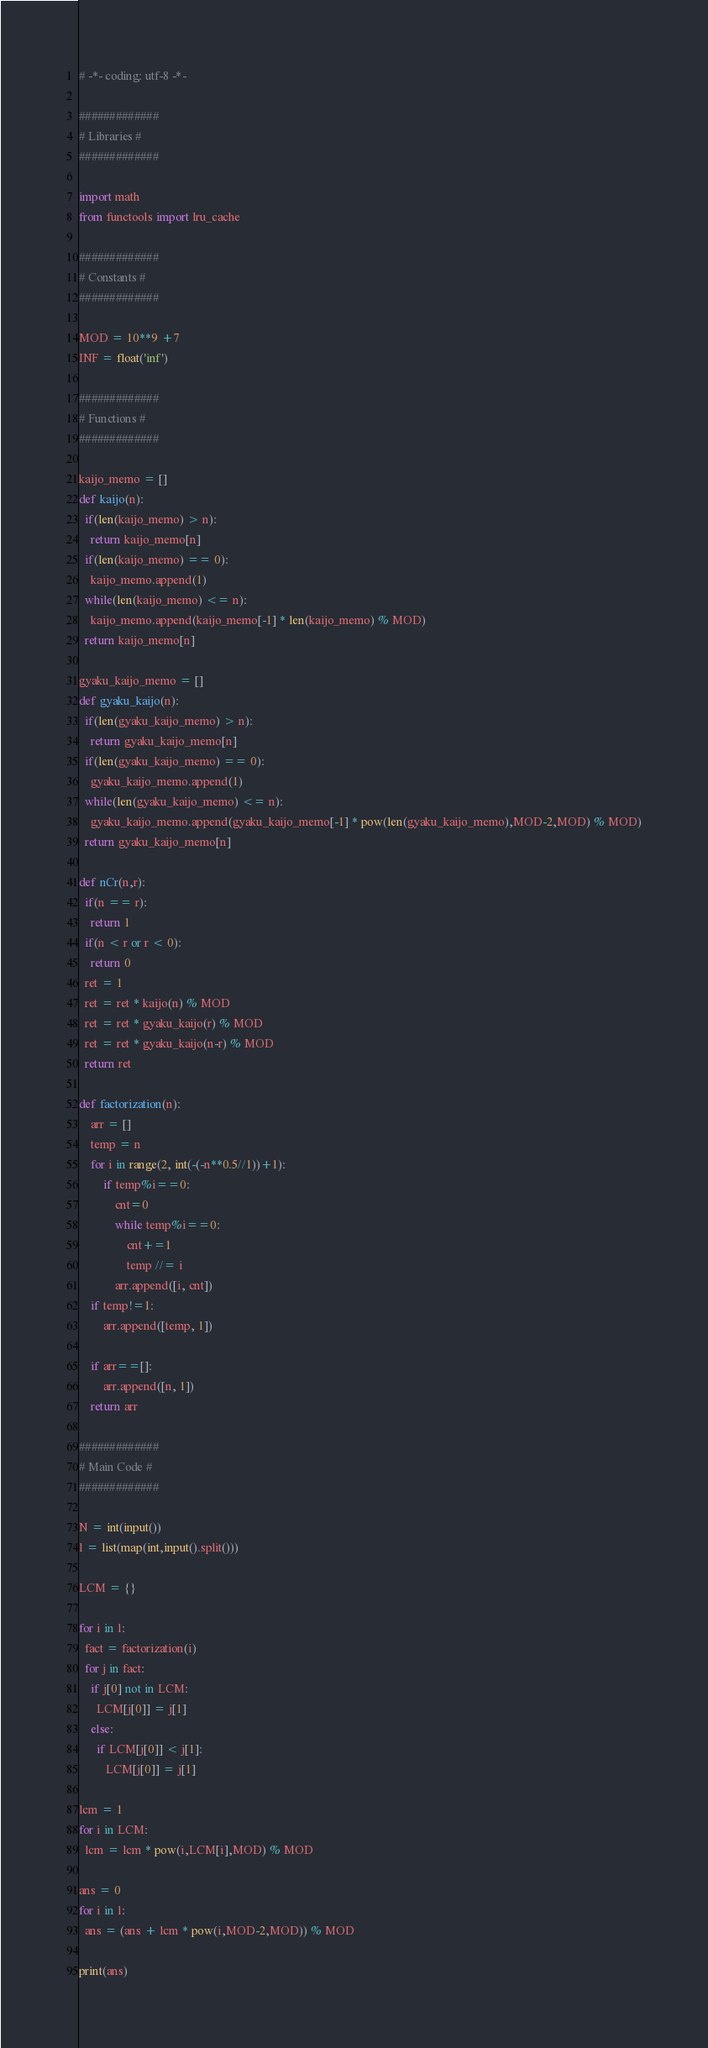Convert code to text. <code><loc_0><loc_0><loc_500><loc_500><_Python_># -*- coding: utf-8 -*-

#############
# Libraries #
#############

import math
from functools import lru_cache

#############
# Constants #
#############

MOD = 10**9 +7
INF = float('inf')

#############
# Functions #
#############

kaijo_memo = []
def kaijo(n):
  if(len(kaijo_memo) > n):
    return kaijo_memo[n]
  if(len(kaijo_memo) == 0):
    kaijo_memo.append(1)
  while(len(kaijo_memo) <= n):
    kaijo_memo.append(kaijo_memo[-1] * len(kaijo_memo) % MOD)
  return kaijo_memo[n]

gyaku_kaijo_memo = []
def gyaku_kaijo(n):
  if(len(gyaku_kaijo_memo) > n):
    return gyaku_kaijo_memo[n]
  if(len(gyaku_kaijo_memo) == 0):
    gyaku_kaijo_memo.append(1)
  while(len(gyaku_kaijo_memo) <= n):
    gyaku_kaijo_memo.append(gyaku_kaijo_memo[-1] * pow(len(gyaku_kaijo_memo),MOD-2,MOD) % MOD)
  return gyaku_kaijo_memo[n]

def nCr(n,r):
  if(n == r):
    return 1
  if(n < r or r < 0):
    return 0
  ret = 1
  ret = ret * kaijo(n) % MOD
  ret = ret * gyaku_kaijo(r) % MOD
  ret = ret * gyaku_kaijo(n-r) % MOD
  return ret

def factorization(n):
    arr = []
    temp = n
    for i in range(2, int(-(-n**0.5//1))+1):
        if temp%i==0:
            cnt=0
            while temp%i==0:
                cnt+=1
                temp //= i
            arr.append([i, cnt])
    if temp!=1:
        arr.append([temp, 1])

    if arr==[]:
        arr.append([n, 1])
    return arr

#############
# Main Code #
#############

N = int(input())
l = list(map(int,input().split()))

LCM = {}

for i in l:
  fact = factorization(i)
  for j in fact:
    if j[0] not in LCM:
      LCM[j[0]] = j[1]
    else:
      if LCM[j[0]] < j[1]:
         LCM[j[0]] = j[1]

lcm = 1
for i in LCM:
  lcm = lcm * pow(i,LCM[i],MOD) % MOD

ans = 0
for i in l:
  ans = (ans + lcm * pow(i,MOD-2,MOD)) % MOD

print(ans)</code> 